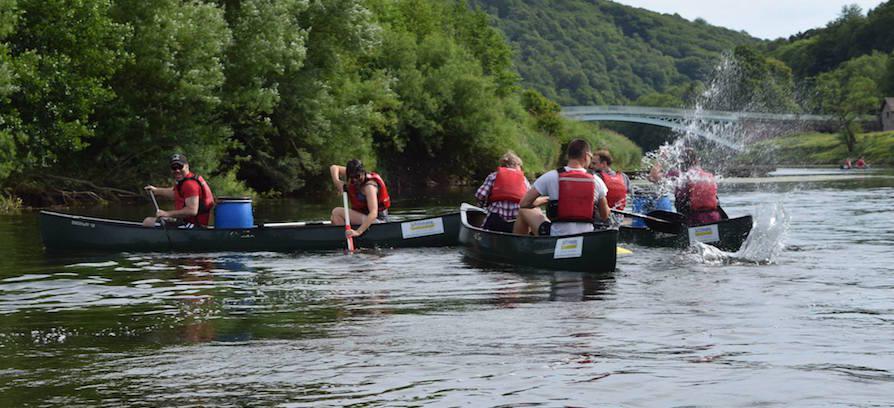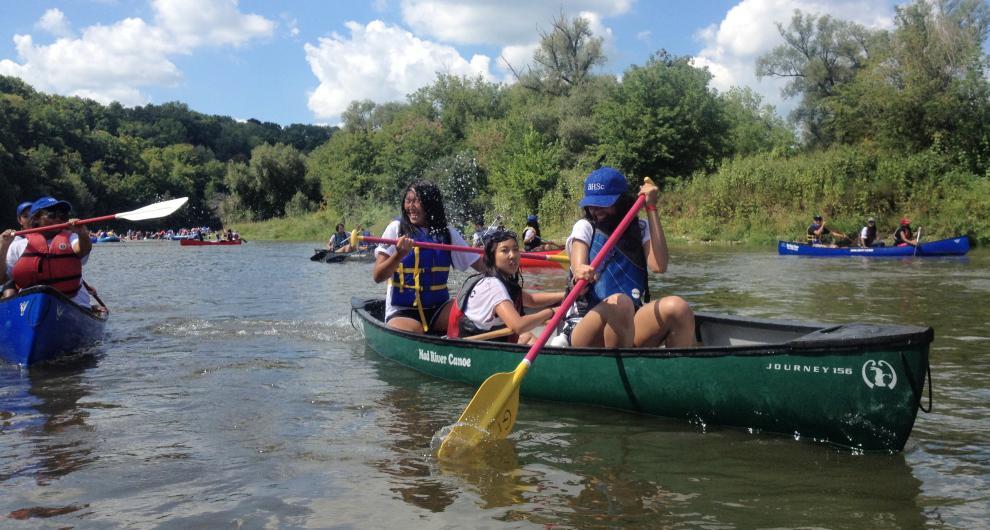The first image is the image on the left, the second image is the image on the right. Analyze the images presented: Is the assertion "There is more than one canoe in each image." valid? Answer yes or no. Yes. 